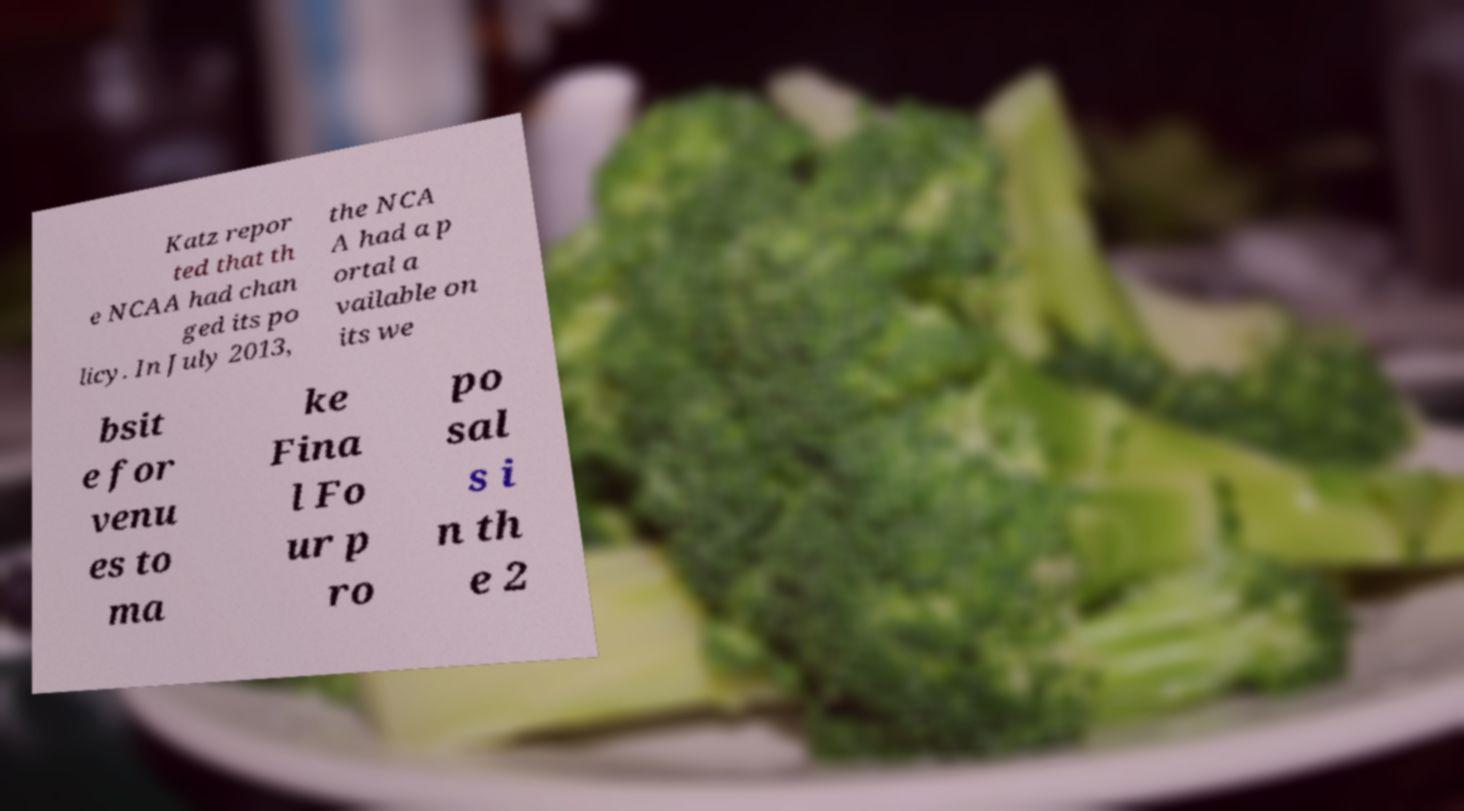Can you accurately transcribe the text from the provided image for me? Katz repor ted that th e NCAA had chan ged its po licy. In July 2013, the NCA A had a p ortal a vailable on its we bsit e for venu es to ma ke Fina l Fo ur p ro po sal s i n th e 2 